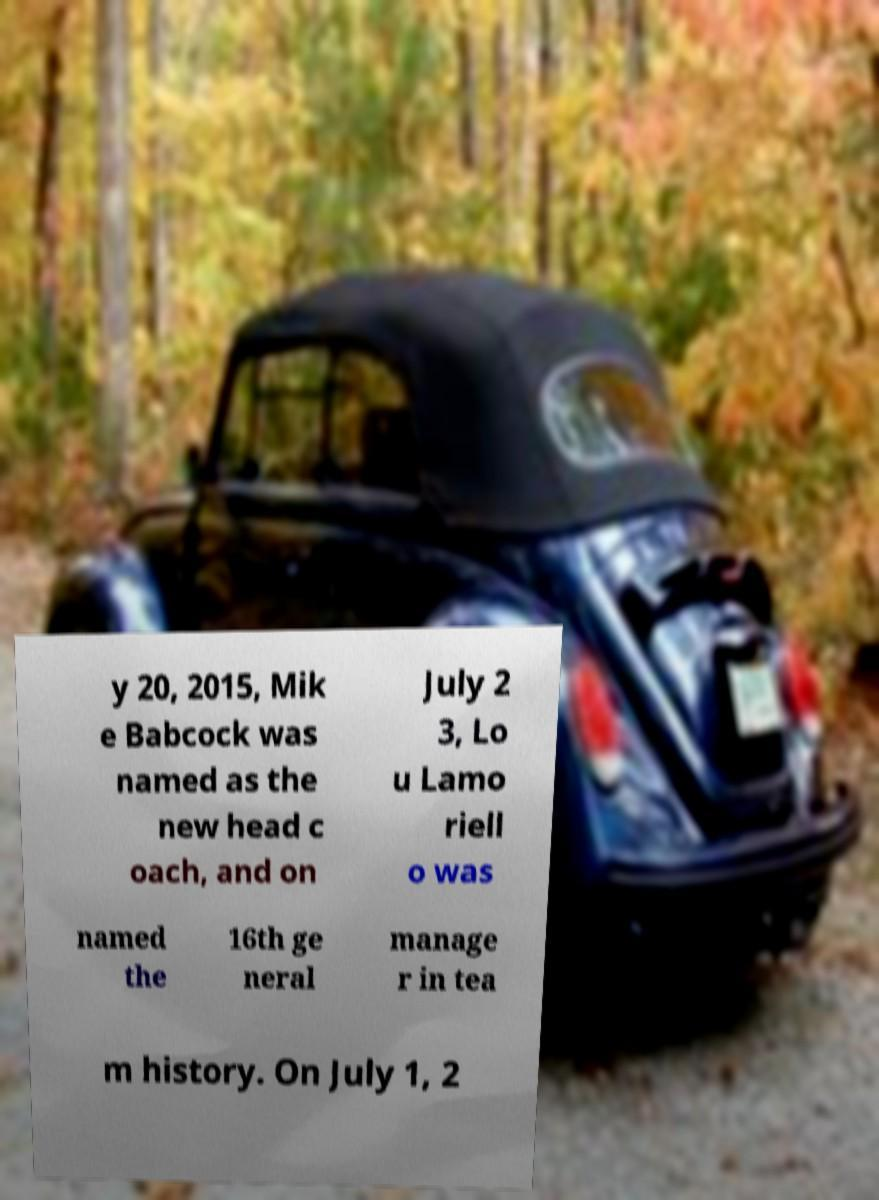Please identify and transcribe the text found in this image. y 20, 2015, Mik e Babcock was named as the new head c oach, and on July 2 3, Lo u Lamo riell o was named the 16th ge neral manage r in tea m history. On July 1, 2 